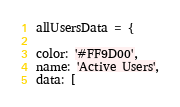<code> <loc_0><loc_0><loc_500><loc_500><_JavaScript_>allUsersData = {
    
color: '#FF9D00',
name: 'Active Users',
data: [</code> 